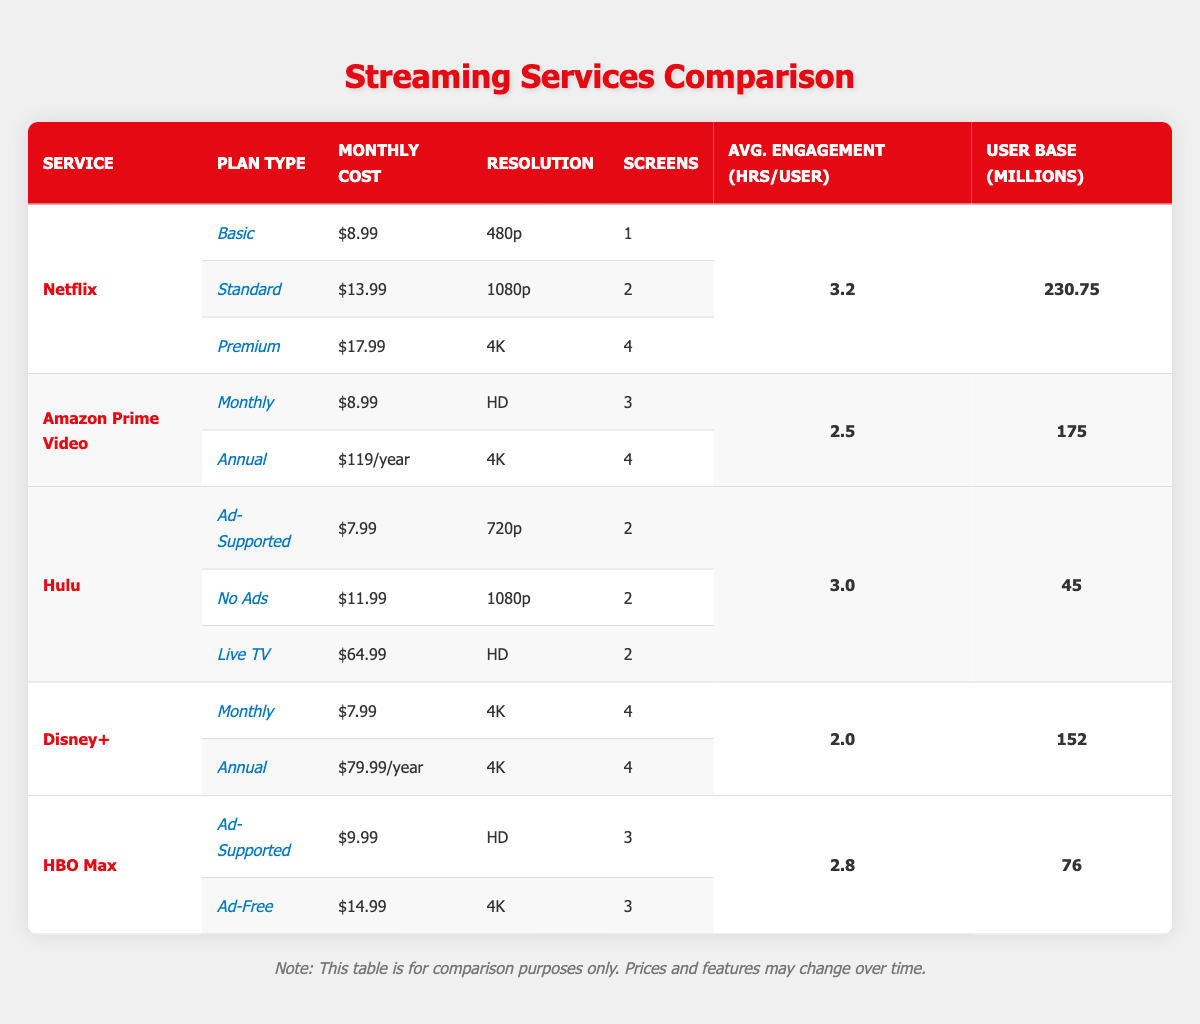What is the monthly cost of Netflix's Premium plan? The table shows Netflix's subscription plans, and the Premium plan is listed with a monthly cost of $17.99.
Answer: $17.99 Which streaming service has the highest average engagement hours per user? By comparing the average engagement hours per user across all services, Netflix (3.2 hours) has the highest value, followed by Hulu (3.0 hours), HBO Max (2.8 hours), Amazon Prime Video (2.5 hours), and Disney+ (2.0 hours).
Answer: Netflix How many screens are available in the Amazon Prime Video Monthly plan? The table indicates that the Amazon Prime Video Monthly plan allows for 3 screens as listed in the subscription plan details.
Answer: 3 What is the total number of users (in millions) for Hulu and HBO Max combined? Hulu has a user base of 45 million and HBO Max has 76 million. Adding these together gives 45 + 76 = 121 million.
Answer: 121 million Is Disney+ more expensive than Hulu's Ad-Supported plan? The monthly cost of Disney+'s Monthly plan is $7.99, while Hulu's Ad-Supported plan costs $7.99 as well. Therefore, Disney+ is not more expensive than Hulu's Ad-Supported plan as they are equal in price.
Answer: No What is the difference in average engagement hours between Netflix and Amazon Prime Video? Netflix has 3.2 average engagement hours per user, while Amazon Prime Video has 2.5. The difference is calculated as 3.2 - 2.5 = 0.7 hours.
Answer: 0.7 hours Which service offers a plan that supports 4K resolution for less than $10? Checking the table, none of the services provide a subscription plan that supports 4K resolution for less than $10. All listed plans offering 4K (Netflix Premium and Disney+ Monthly) are above $10.
Answer: No How much does the Hulu Live TV plan cost? The table specifies that the Live TV plan for Hulu costs $64.99 per month.
Answer: $64.99 What percentage of Netflix's user base is greater than that of Hulu? Netflix has a user base of 230.75 million while Hulu has 45 million. To find the percentage of Netflix's user base that is greater, the calculation is (230.75 - 45) / 45 * 100% = 413.89%.
Answer: 413.89% 